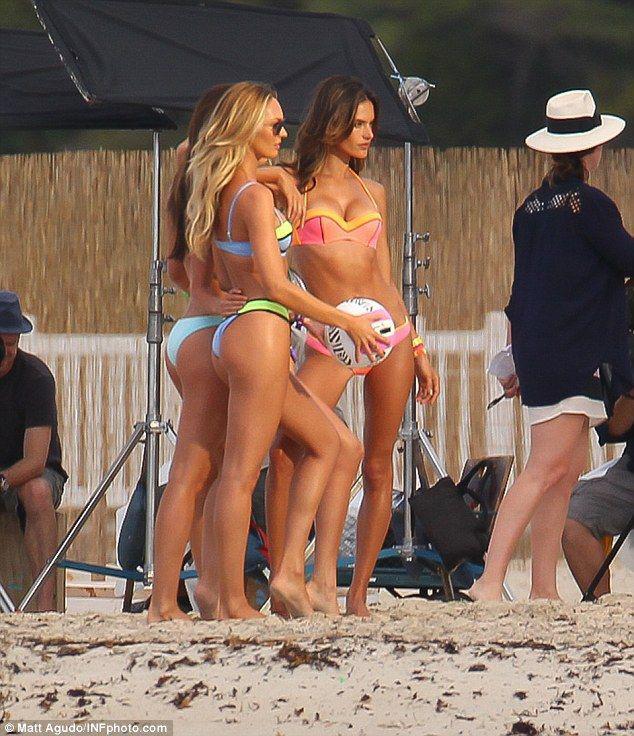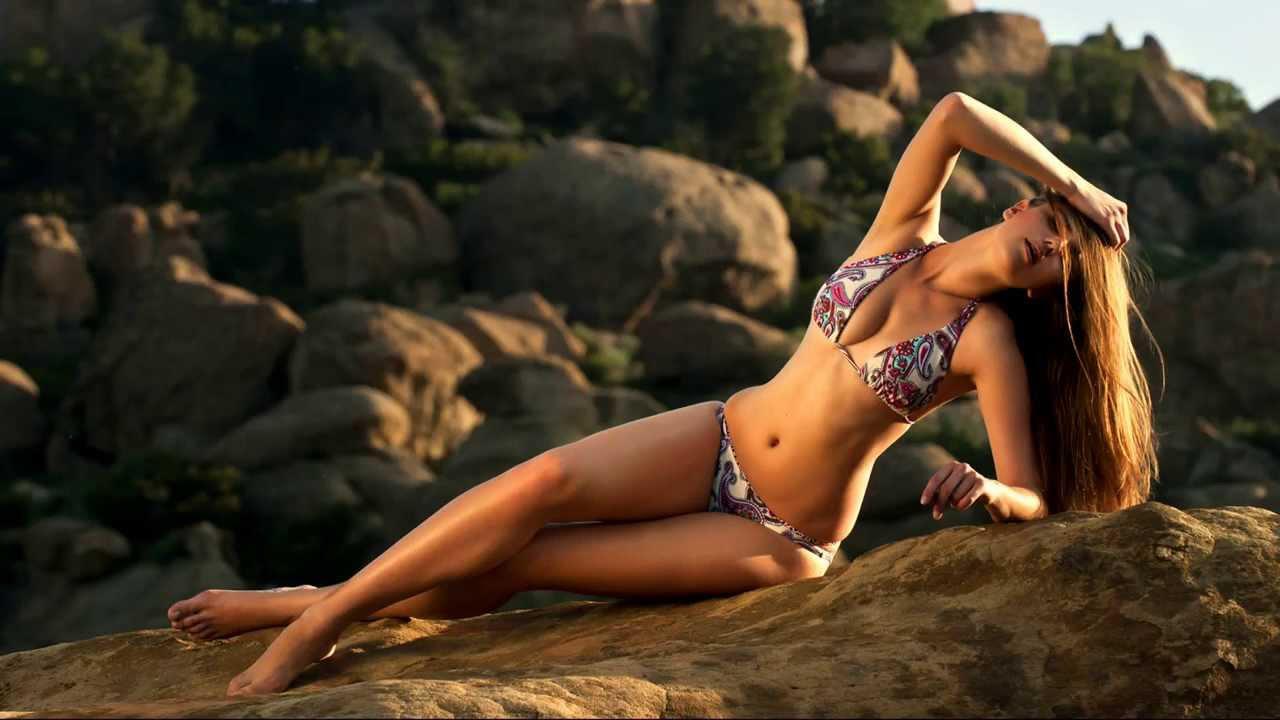The first image is the image on the left, the second image is the image on the right. Examine the images to the left and right. Is the description "The right image shows one blonde model in a printed bikini with the arm on the left raised to her head and boulders behind her." accurate? Answer yes or no. Yes. The first image is the image on the left, the second image is the image on the right. Analyze the images presented: Is the assertion "There are exactly two women." valid? Answer yes or no. No. 